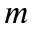Convert formula to latex. <formula><loc_0><loc_0><loc_500><loc_500>m</formula> 